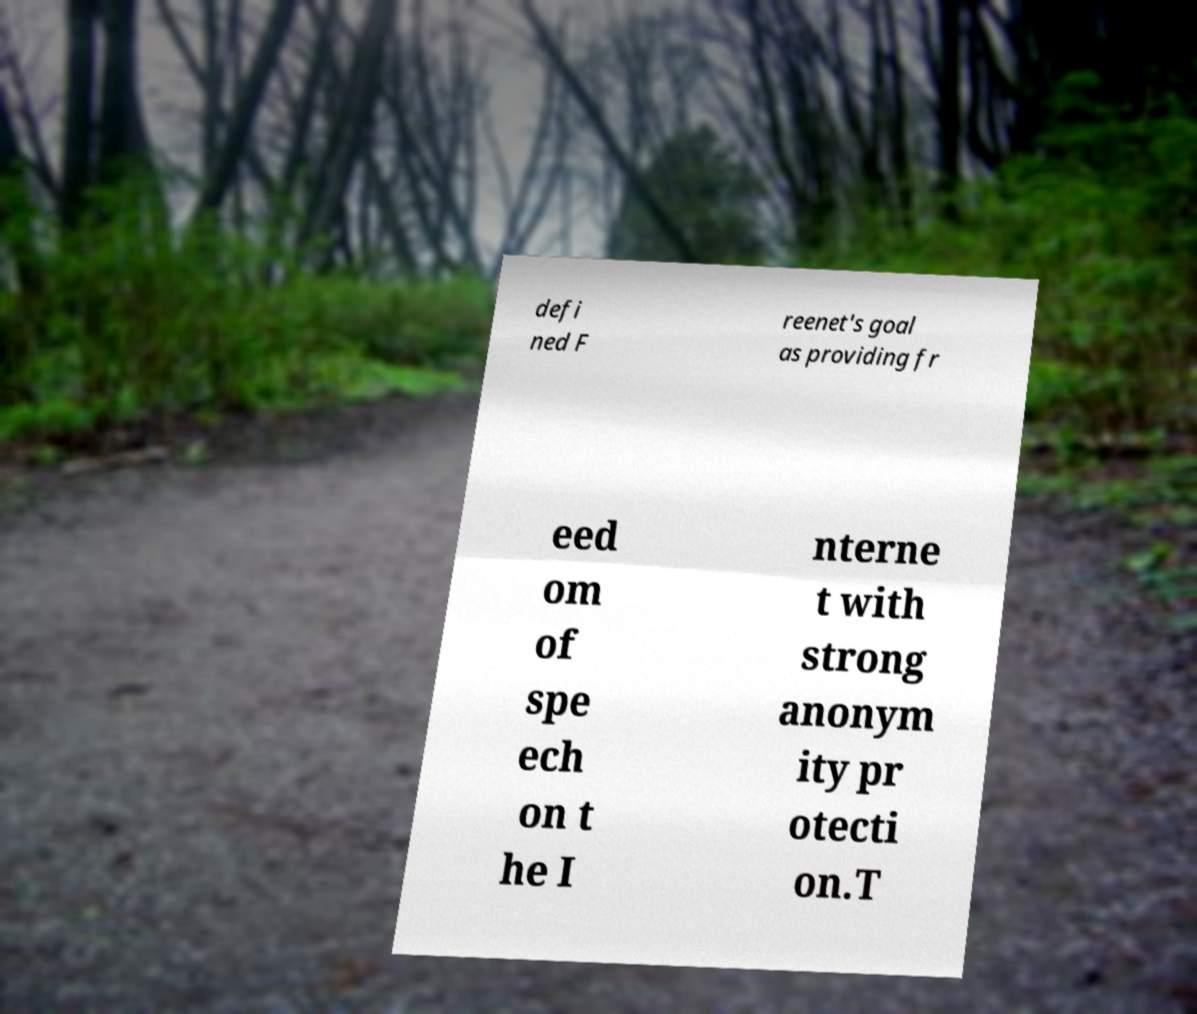Could you extract and type out the text from this image? defi ned F reenet's goal as providing fr eed om of spe ech on t he I nterne t with strong anonym ity pr otecti on.T 